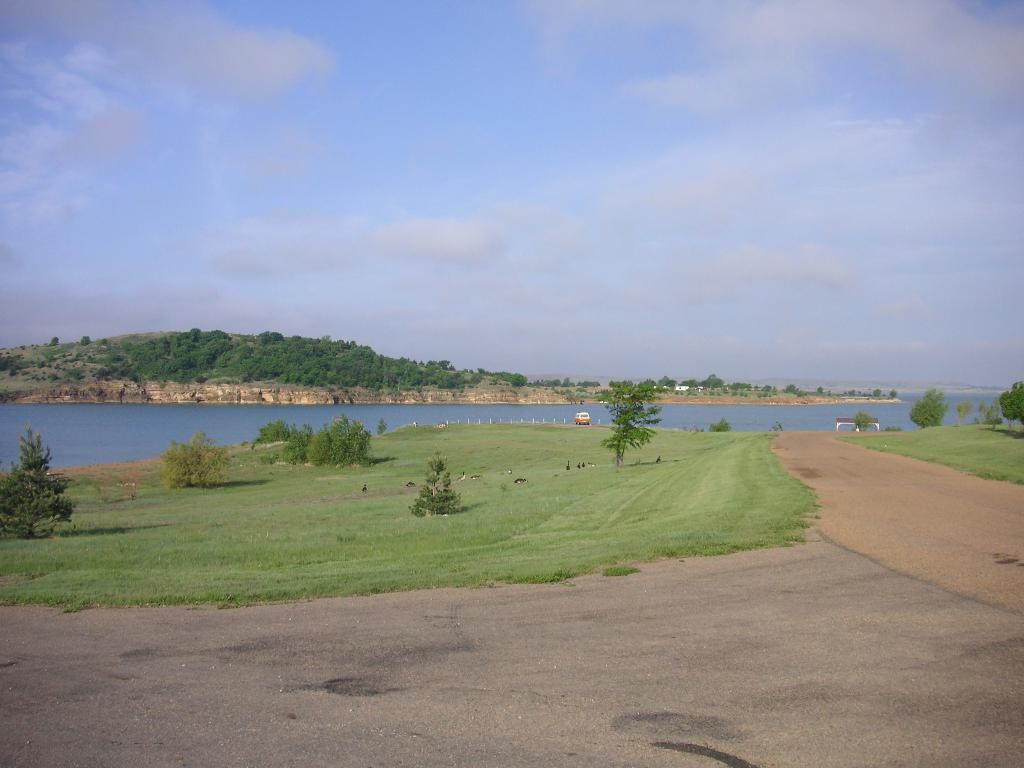What type of vehicle is in the image? The facts do not specify the type of vehicle. What animals can be seen on the grass in the image? There are birds on the grass in the image. What architectural features are present in the image? There are stone pillars in the image. What natural element is visible in the image? Water is visible in the image. What type of vegetation is present in the image? There are trees in the image. What type of structure is in the image? There is a house in the image. What geographical feature is visible in the image? There are mountains in the image. What is visible in the sky in the image? There are clouds in the sky in the image. Can you find the receipt for the vehicle purchase in the image? There is no mention of a receipt or vehicle purchase in the image. Is there a rainstorm happening in the image? There is no indication of a rainstorm in the image; the sky is described as having clouds. 